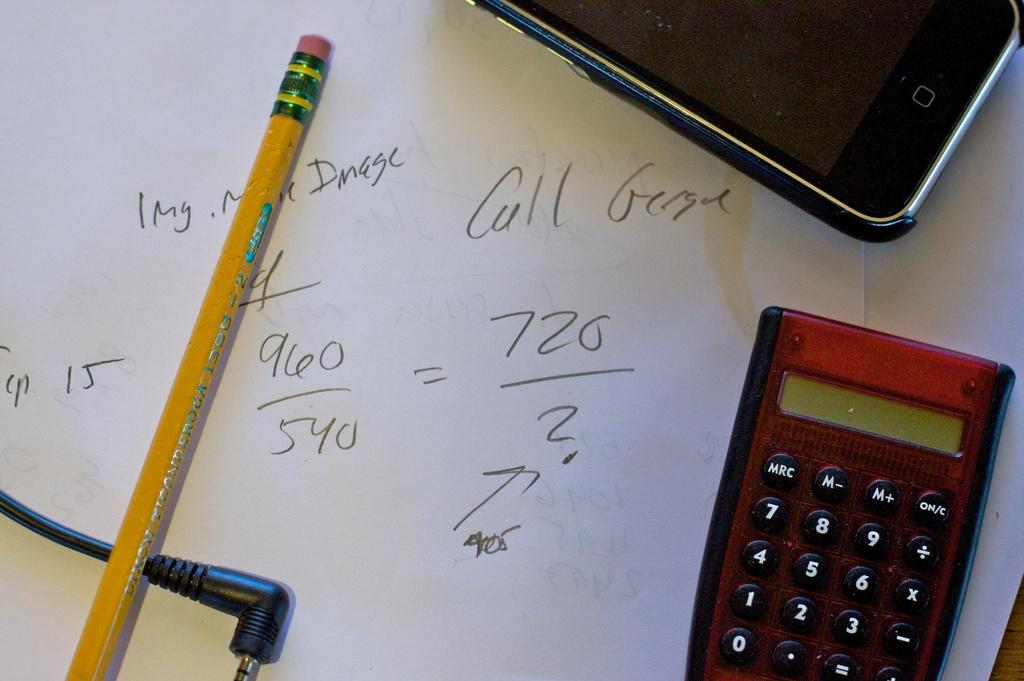What stationery item is present in the image? There is a pencil in the image. What is the pencil placed near in the image? There is paper in the image. What other object can be seen in the image that is not related to writing or drawing? There is wire in the image. What electronic device is present in the image? There is a mobile phone in the image. What device is present in the image that is commonly used for calculations? There is a calculator in the image. What type of fruit can be seen hanging from the wire in the image? There is no fruit hanging from the wire in the image. What type of tree can be seen growing from the calculator in the image? There is no tree growing from the calculator in the image. 